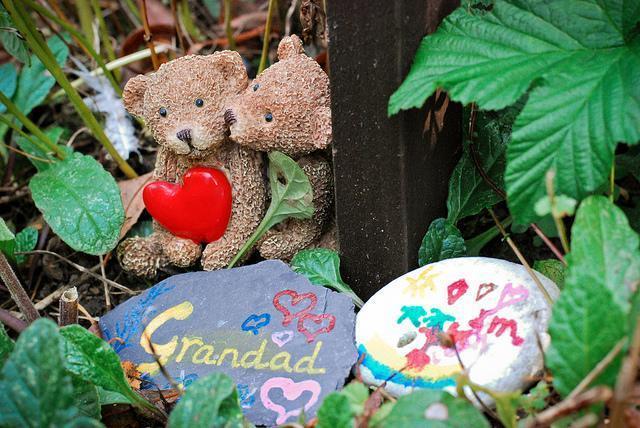How many teddy bears are in the picture?
Give a very brief answer. 2. How many people are wearing yellow and red jackets?
Give a very brief answer. 0. 